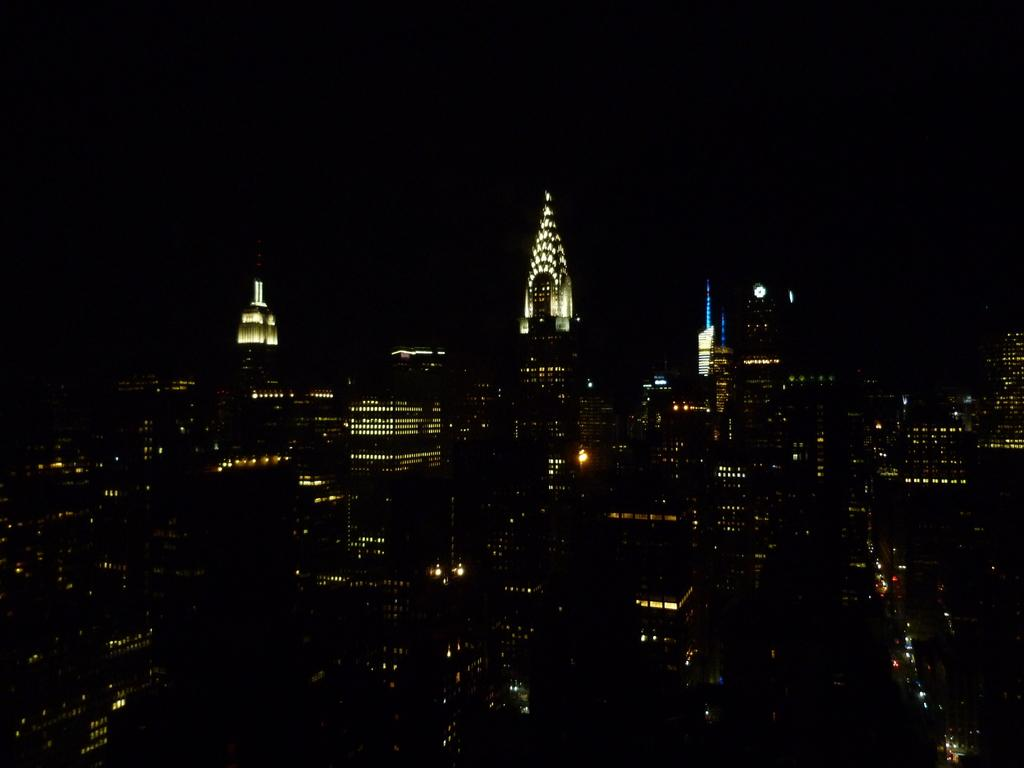What structures are located in the foreground of the image? There are buildings and skyscrapers in the foreground of the image. What feature do the buildings and skyscrapers have? The buildings and skyscrapers have lights. What is the color of the background in the image? The background of the image is dark. What type of jelly can be seen on the roof of the buildings in the image? There is no jelly present on the roof of the buildings in the image. How does the baby contribute to the illumination of the buildings in the image? There is no baby present in the image, so it cannot contribute to the illumination of the buildings. 